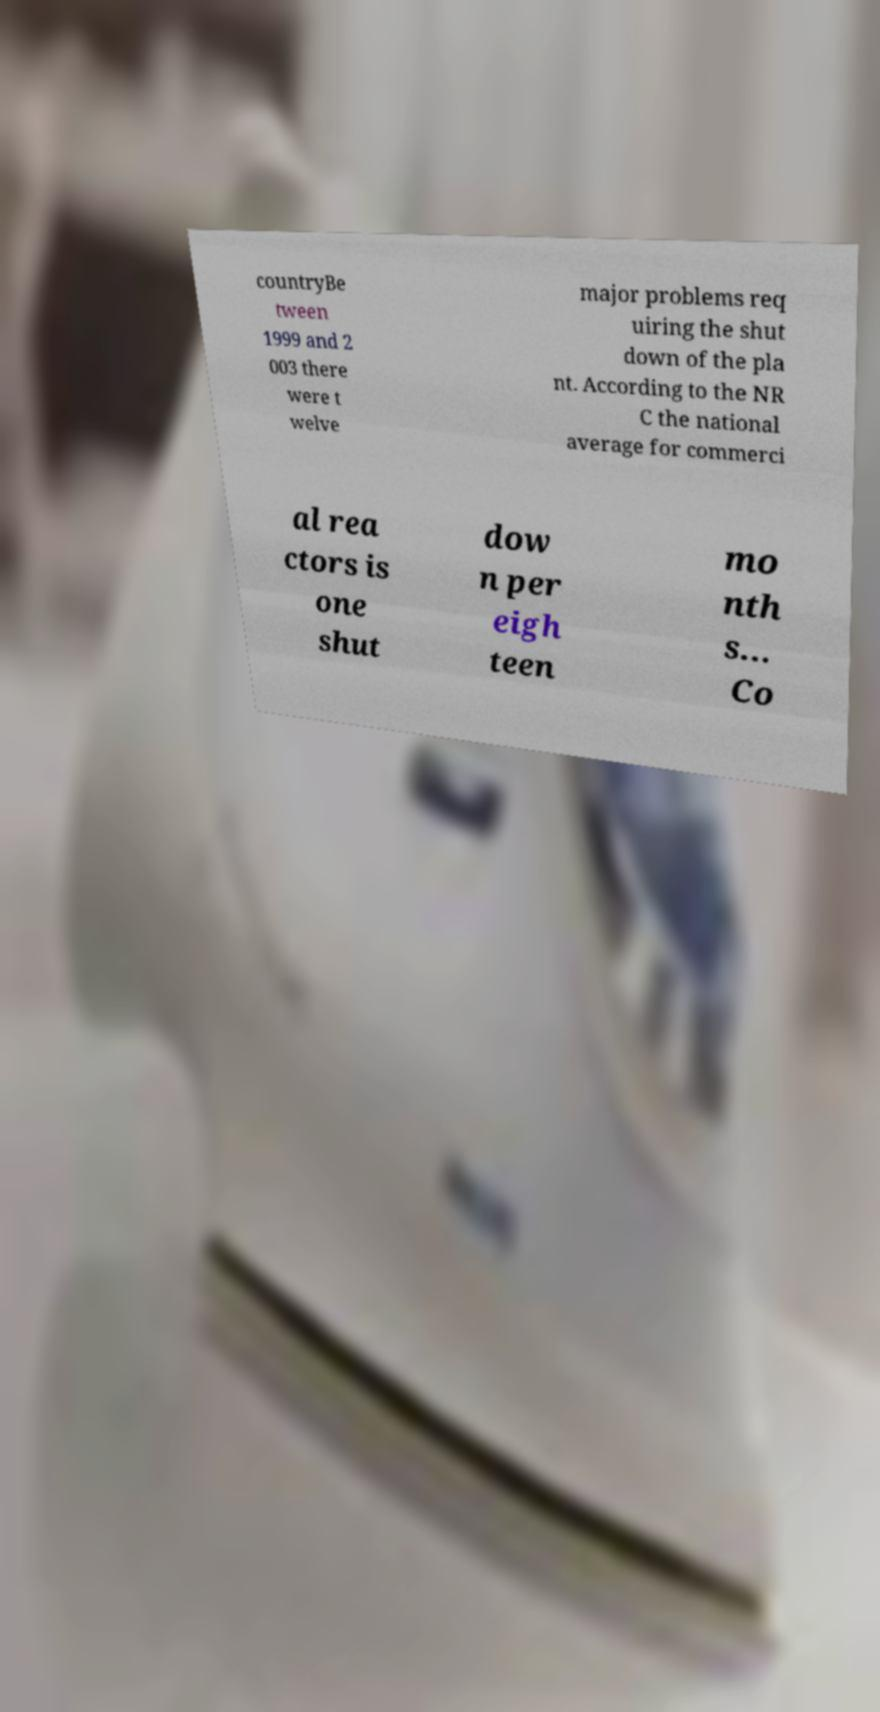Please read and relay the text visible in this image. What does it say? countryBe tween 1999 and 2 003 there were t welve major problems req uiring the shut down of the pla nt. According to the NR C the national average for commerci al rea ctors is one shut dow n per eigh teen mo nth s... Co 